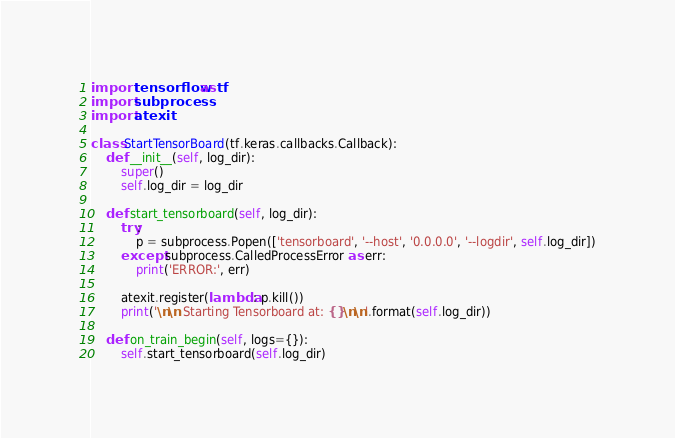<code> <loc_0><loc_0><loc_500><loc_500><_Python_>import tensorflow as tf
import subprocess
import atexit

class StartTensorBoard(tf.keras.callbacks.Callback):
    def __init__(self, log_dir):
        super()
        self.log_dir = log_dir
        
    def start_tensorboard(self, log_dir):
        try:
            p = subprocess.Popen(['tensorboard', '--host', '0.0.0.0', '--logdir', self.log_dir])
        except subprocess.CalledProcessError as err:
            print('ERROR:', err)
            
        atexit.register(lambda: p.kill())    
        print('\n\n Starting Tensorboard at: {}\n\n'.format(self.log_dir))
        
    def on_train_begin(self, logs={}):
        self.start_tensorboard(self.log_dir)
</code> 